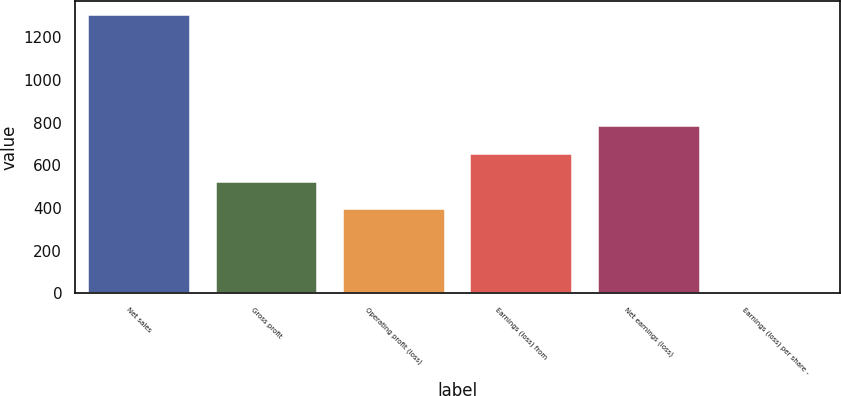Convert chart. <chart><loc_0><loc_0><loc_500><loc_500><bar_chart><fcel>Net sales<fcel>Gross profit<fcel>Operating profit (loss)<fcel>Earnings (loss) from<fcel>Net earnings (loss)<fcel>Earnings (loss) per share -<nl><fcel>1304<fcel>523.13<fcel>392.98<fcel>653.28<fcel>783.43<fcel>2.53<nl></chart> 